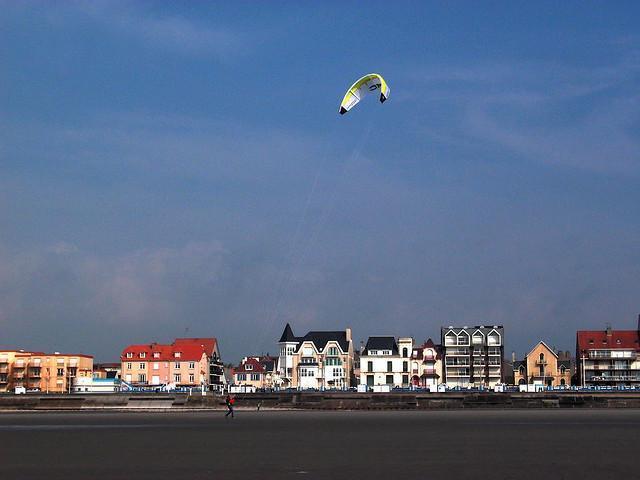How many clock faces are there?
Give a very brief answer. 0. How many giraffe are standing next to each other?
Give a very brief answer. 0. 